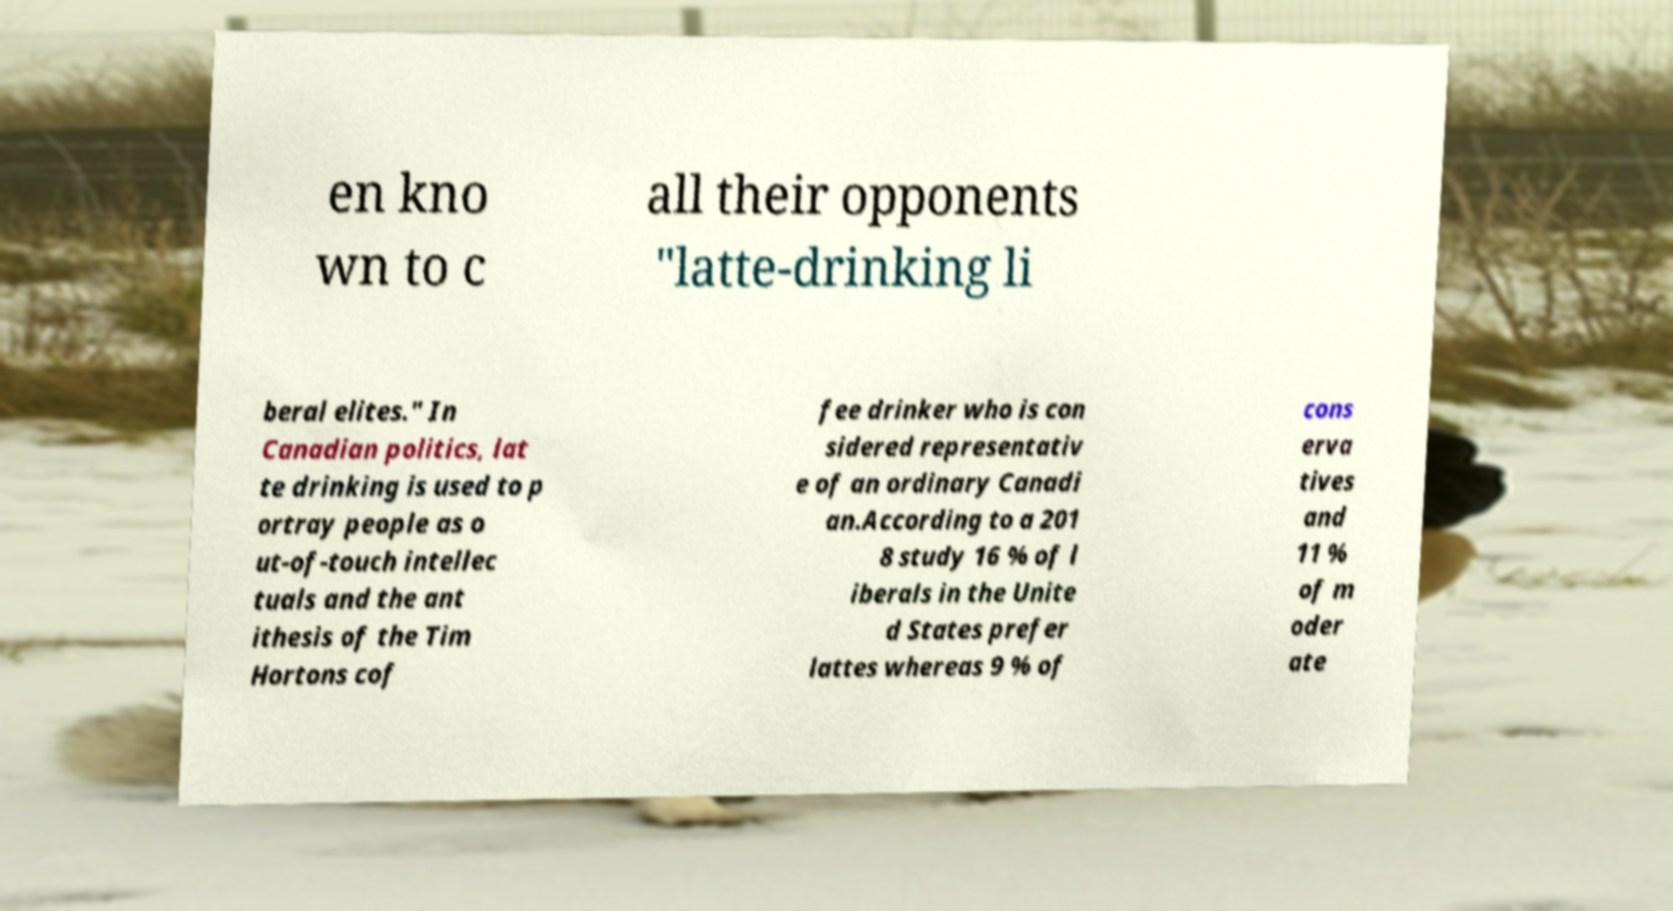I need the written content from this picture converted into text. Can you do that? en kno wn to c all their opponents "latte-drinking li beral elites." In Canadian politics, lat te drinking is used to p ortray people as o ut-of-touch intellec tuals and the ant ithesis of the Tim Hortons cof fee drinker who is con sidered representativ e of an ordinary Canadi an.According to a 201 8 study 16 % of l iberals in the Unite d States prefer lattes whereas 9 % of cons erva tives and 11 % of m oder ate 